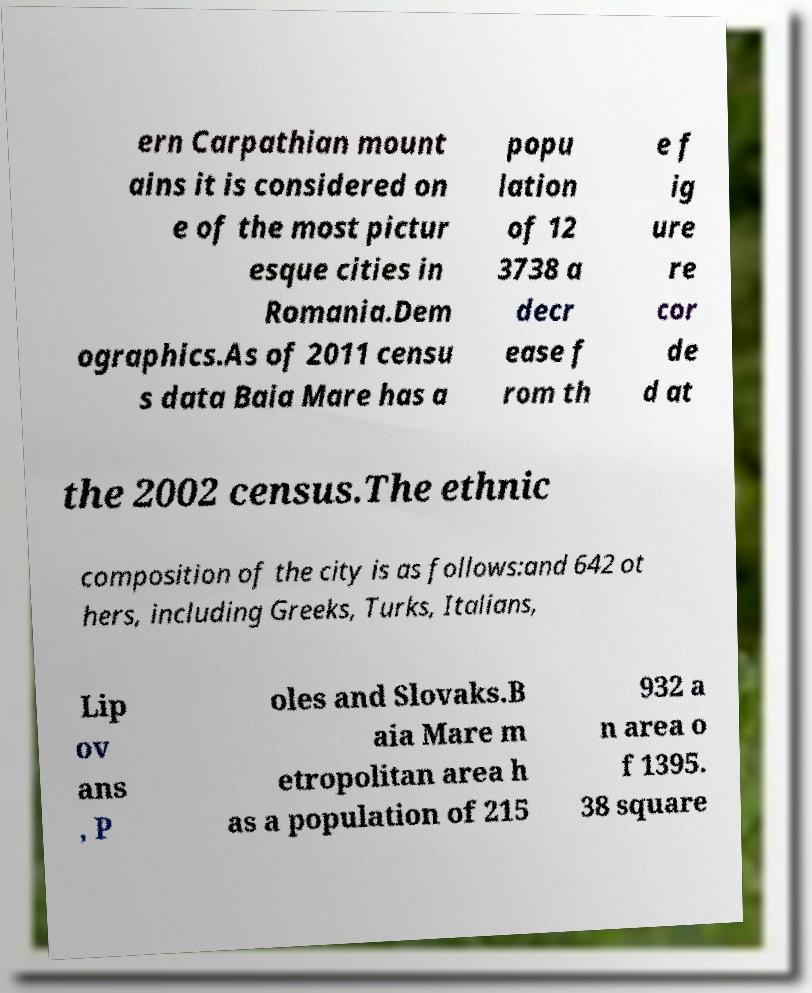There's text embedded in this image that I need extracted. Can you transcribe it verbatim? ern Carpathian mount ains it is considered on e of the most pictur esque cities in Romania.Dem ographics.As of 2011 censu s data Baia Mare has a popu lation of 12 3738 a decr ease f rom th e f ig ure re cor de d at the 2002 census.The ethnic composition of the city is as follows:and 642 ot hers, including Greeks, Turks, Italians, Lip ov ans , P oles and Slovaks.B aia Mare m etropolitan area h as a population of 215 932 a n area o f 1395. 38 square 